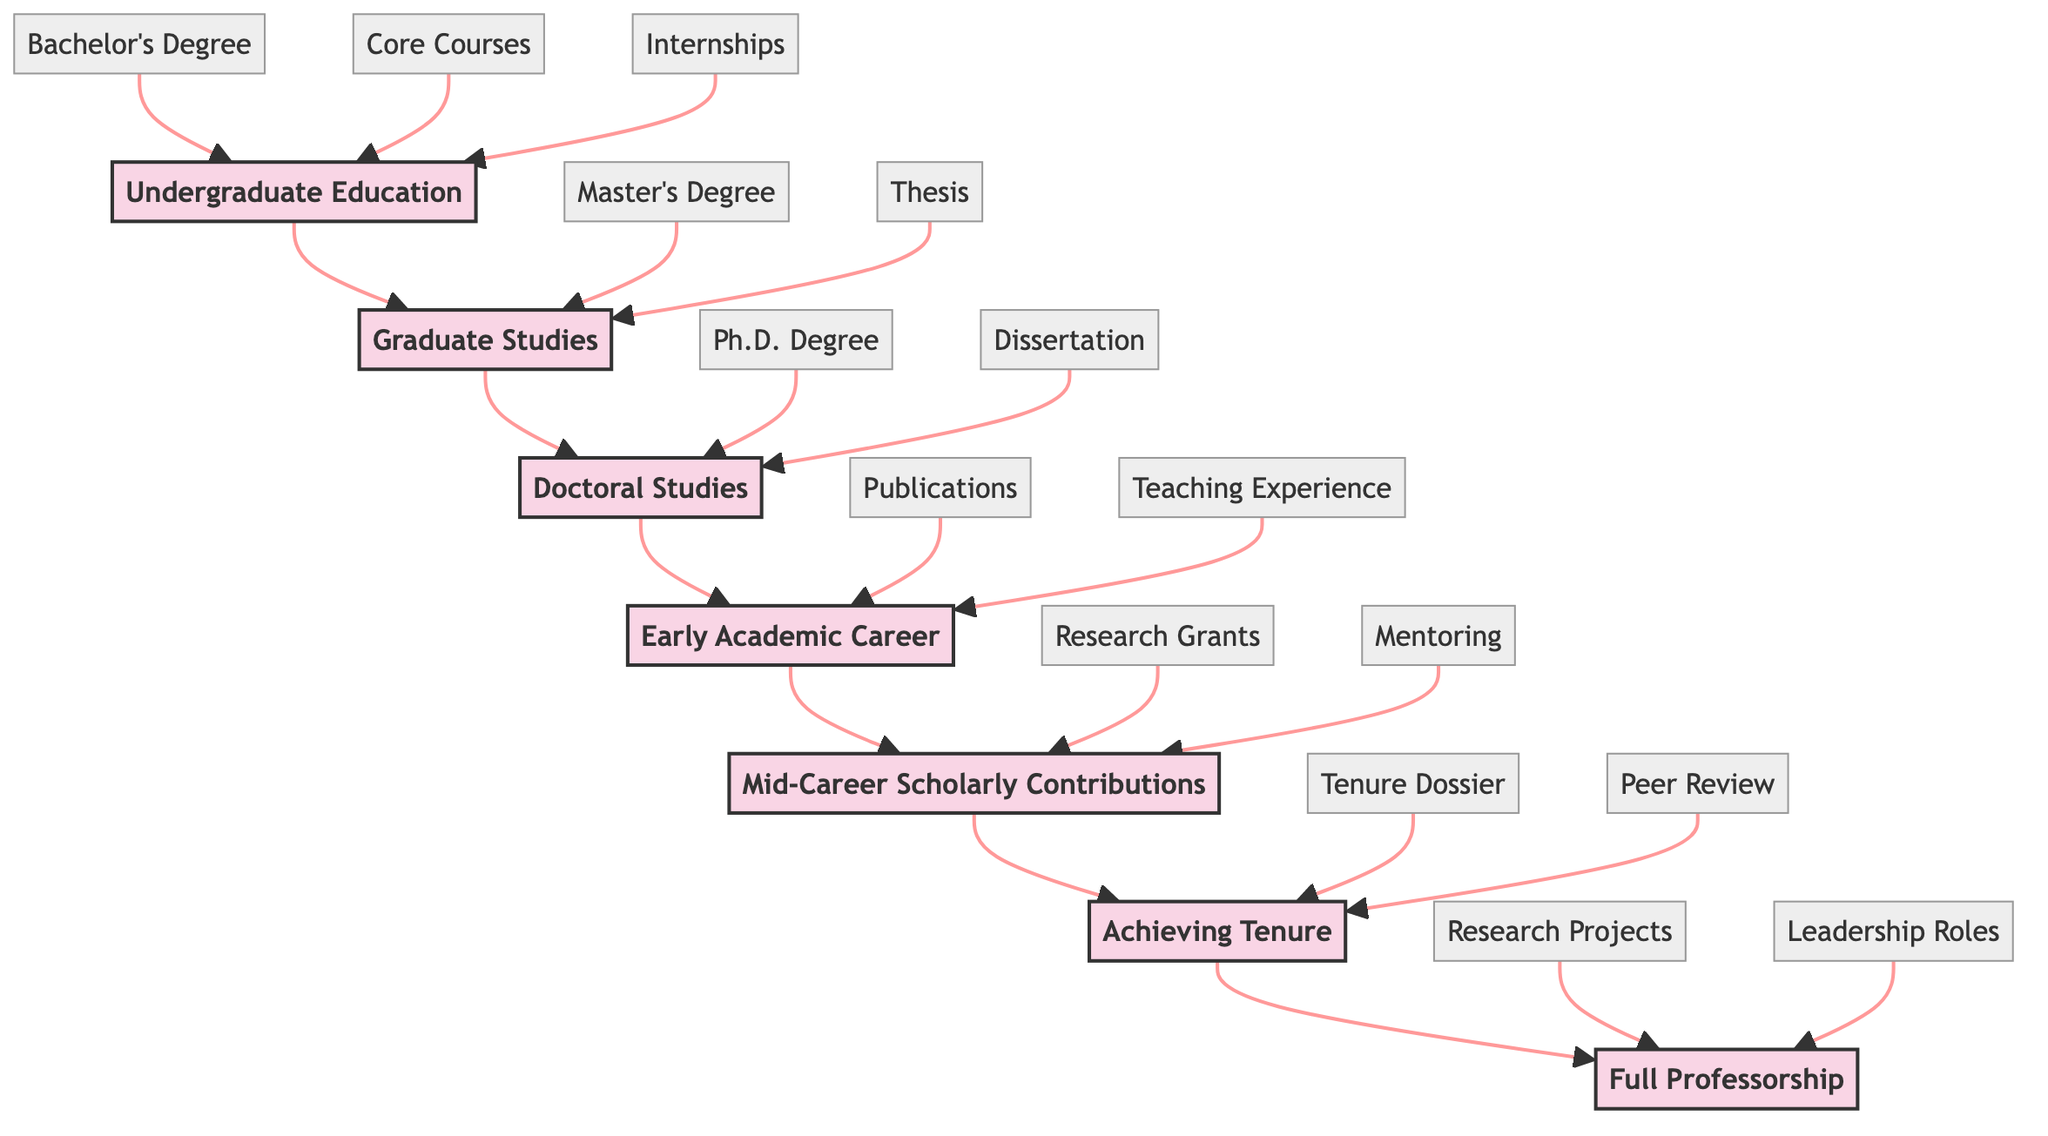What is the first stage in the academic career progression? The diagram begins with the stage labeled "Undergraduate Education," which is the first step in the academic career path.
Answer: Undergraduate Education How many key elements are associated with Doctoral Studies? In the diagram, the key elements listed under "Doctoral Studies" are six in number: Acceptance into a Ph.D. Program, Advanced Coursework and Qualifying Exams, Identifying Research Topics and Dissertation Proposal, Conducting Original Research, Writing and Defending the Dissertation, and Achieving Ph.D. Degree.
Answer: 6 What follows after the Early Academic Career stage? Looking at the flow of the diagram, the next stage that follows after "Early Academic Career" is "Mid-Career Scholarly Contributions." The arrows indicate the progression from one stage to the next.
Answer: Mid-Career Scholarly Contributions What degree is achieved after completing the Master's Program? According to the flow chart, individuals achieve the degree labeled "Master's Degree" after completing the "Graduate Studies" stage, which includes a thesis or capstone project.
Answer: Master's Degree Which stage requires assembling a tenure dossier? The diagram indicates that "Achieving Tenure" is the stage where compiling a tenure dossier, which encompasses teaching, research, and service, is required. This is an essential step in pursuing tenure.
Answer: Achieving Tenure How many stages are there in total? By counting the stages listed in the flowchart, we can see there are a total of 7 stages: Undergraduate Education, Graduate Studies, Doctoral Studies, Early Academic Career, Mid-Career Scholarly Contributions, Achieving Tenure, and Full Professorship.
Answer: 7 What is the final step in the academic career progression? The last stage in the upward flow of the diagram is labeled "Full Professorship," indicating it is the endpoint of the academic career progression.
Answer: Full Professorship Which stage involves publishing research papers? The stage where publishing research papers is applicable is "Early Academic Career." This stage highlights the importance of initiating publications within academic journals.
Answer: Early Academic Career What major role is associated with Full Professorship? The diagram points out that one major role associated with "Full Professorship" is "Leading Major Research Projects," which emphasizes the responsibilities of a full professor in research leadership.
Answer: Leading Major Research Projects 